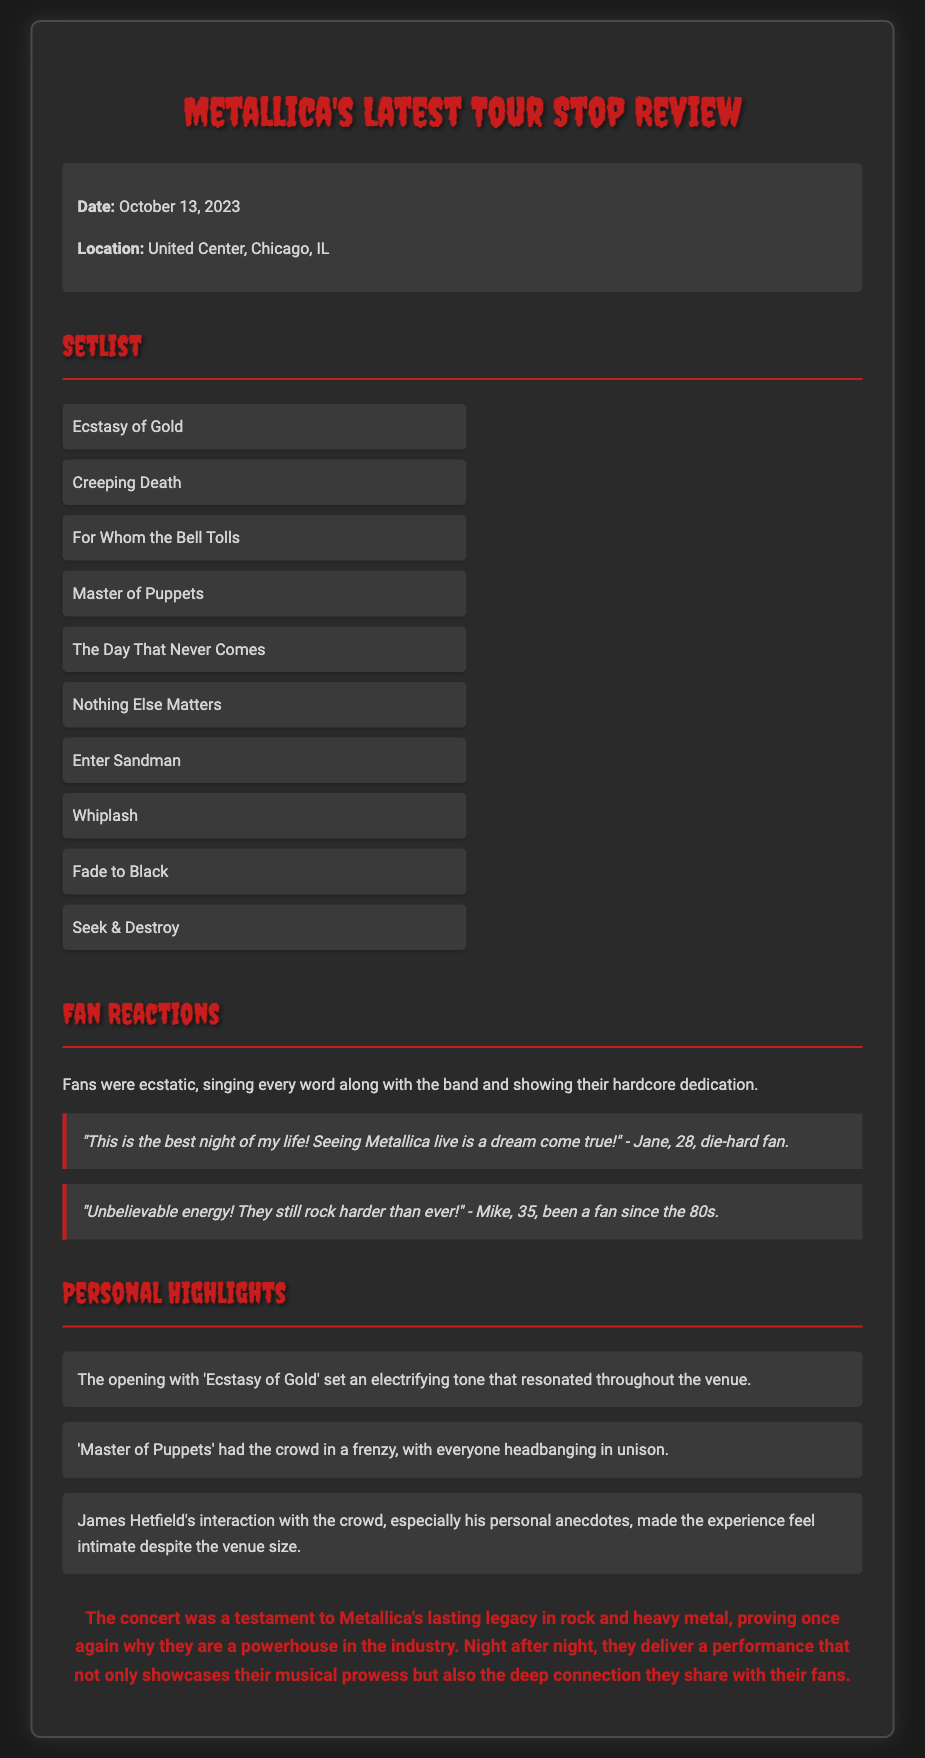What was the date of the concert? The concert date is explicitly mentioned in the document.
Answer: October 13, 2023 Where did the concert take place? The location of the concert is specified in the document.
Answer: United Center, Chicago, IL What song opened the concert? The opening song is highlighted in the personal highlights section of the document.
Answer: Ecstasy of Gold Which song had the crowd in a frenzy? The document mentions what song caused a strong reaction from the crowd in the personal highlights section.
Answer: Master of Puppets How did fans describe the concert experience? The document presents fan reactions that summarize their feelings about the concert.
Answer: Best night of my life Who gave a notable quote about the energy at the concert? The document includes quotes from fans, indicating someone who expressed excitement.
Answer: Mike What is emphasized about Metallica in the closing thoughts? The closing thoughts section summarizes the paper's final remarks about the band’s impact.
Answer: Lasting legacy What was a crowd interaction highlighted in the concert? The personal highlights section mentions an interaction aspect by James Hetfield.
Answer: Personal anecdotes 